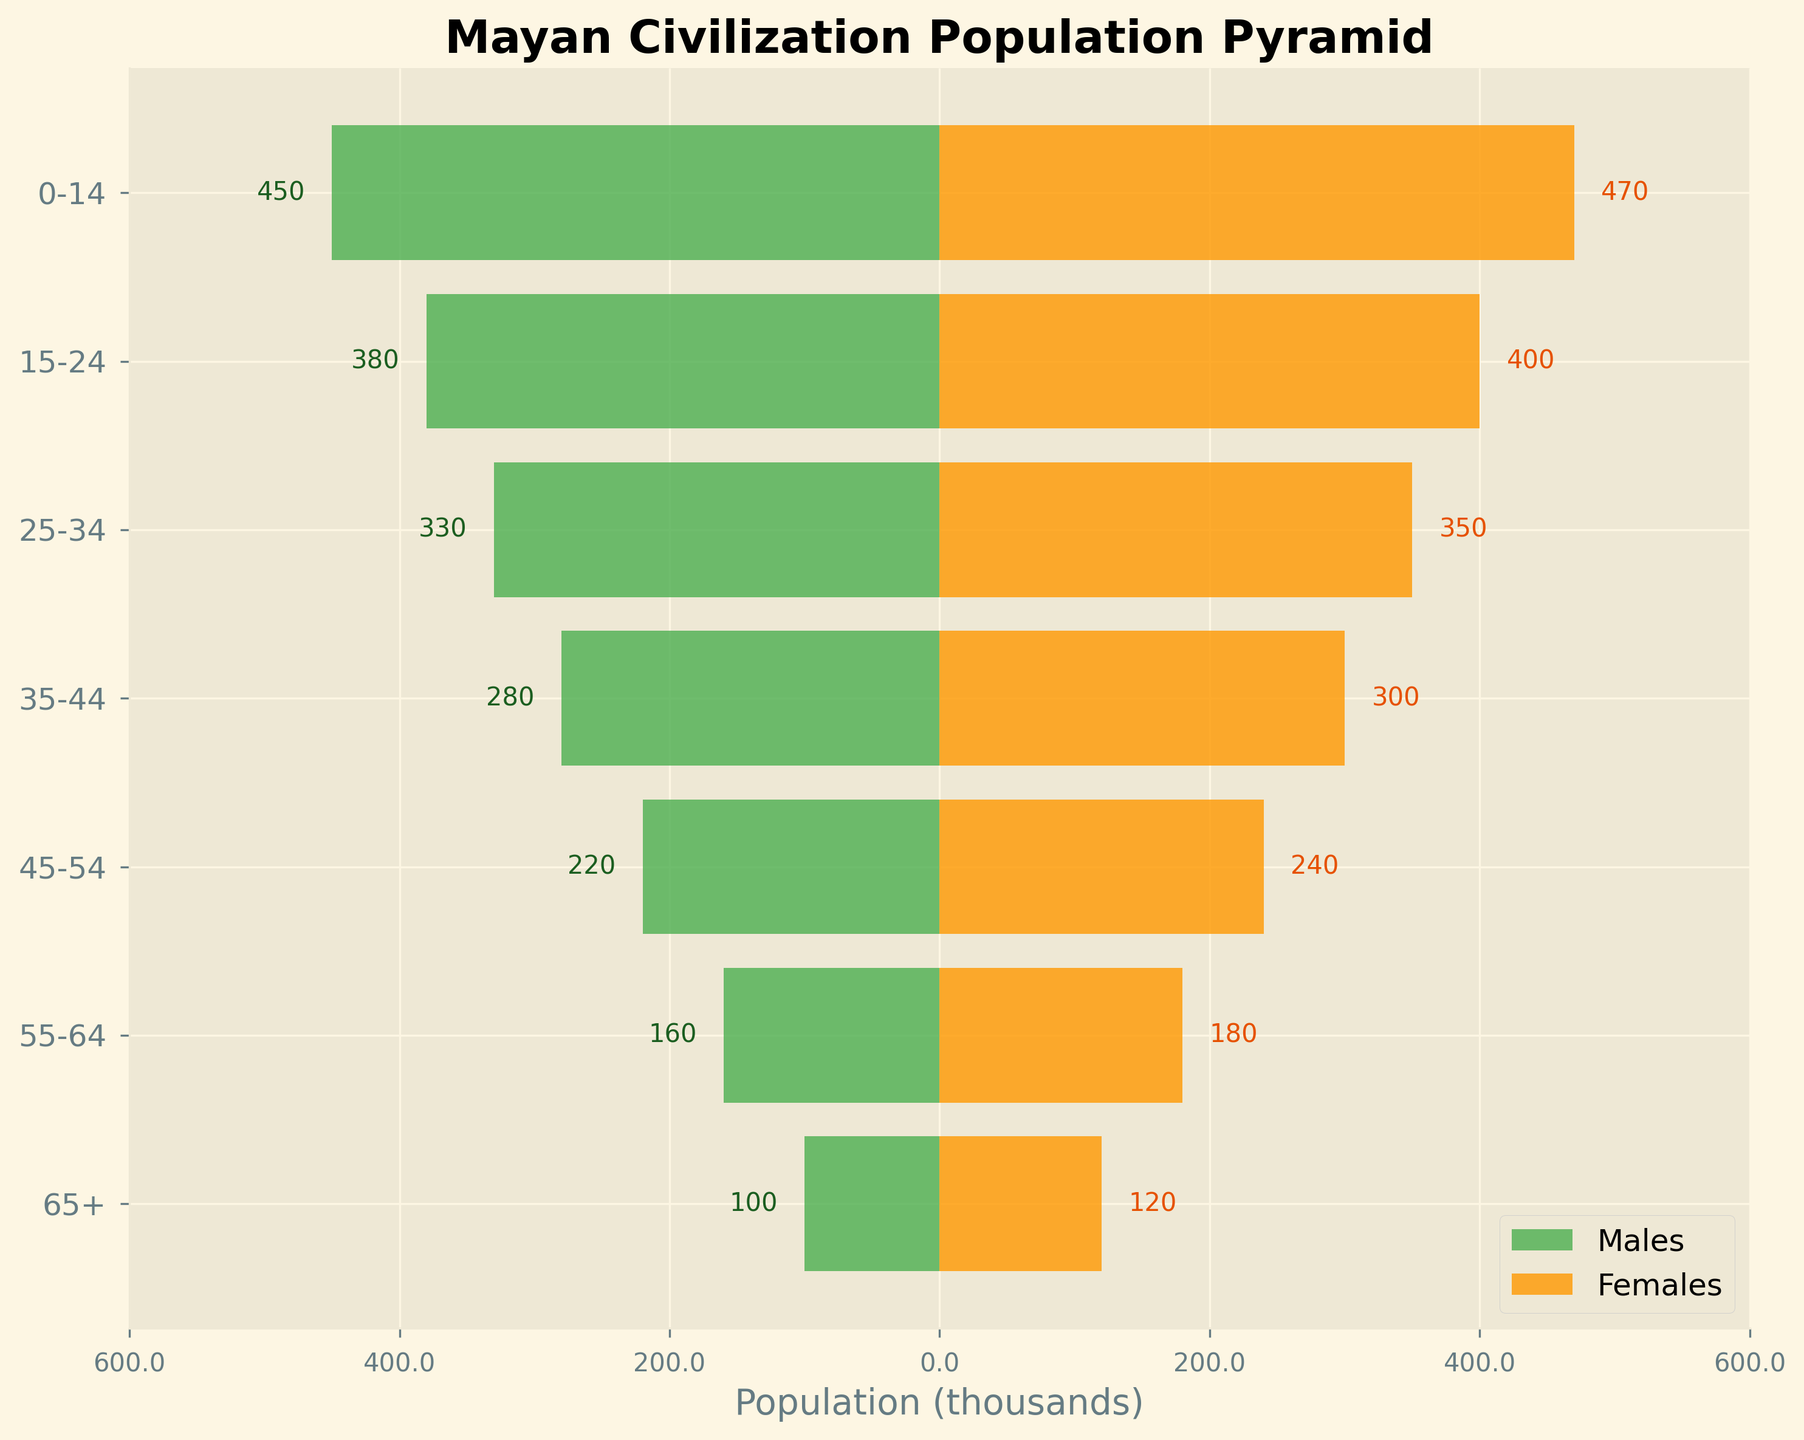What is the title of the figure? The title is written at the top of the figure, summarizing what the data represents.
Answer: Mayan Civilization Population Pyramid Which gender has a higher population in the 0-14 age group? Compare the bar lengths for Males and Females in the 0-14 age group. The orange bar (Females) is longer than the green bar (Males) in this category.
Answer: Females What is the population (in thousands) of Males in the 15-24 age group? Look at the horizontal length of the green bar representing Males in the 15-24 age group. The number is also displayed near the bar. It reads 380.
Answer: 380 What is the difference in population between Males and Females in the 55-64 age group? Subtract the population of Males from Females in the 55-64 age group. Population of Males is 160,000 and Females is 180,000. The difference is 180,000 - 160,000.
Answer: 20,000 Which age group has the smallest female population? Find the shortest orange bar (Females) among all the age groups. The shortest bar belongs to the 65+ age group.
Answer: 65+ What is the total population (in thousands) of the Mayan civilization based on the given data? Add up the populations for Males and Females across all age groups. Total Males are 450 + 380 + 330 + 280 + 220 + 160 + 100 = 1920. Total Females are 470 + 400 + 350 + 300 + 240 + 180 + 120 = 2060. The sum is 1920 + 2060.
Answer: 3980 Which gender has a higher population in the 25-34 age group, and by how much? Compare the populations of Males and Females in the 25-34 age group. Females have 350,000 and Males have 330,000. Subtract Males from Females to find the difference.
Answer: Females, 20,000 How does the population of Males in the 45-54 age group compare to that in the 35-44 age group? Compare the lengths of the green bars for Males in both age groups. The 35-44 group has 280,000 Males, and the 45-54 group has 220,000 Males. The population decreases.
Answer: Decreases What is the average population of Females in the 25-34 and 35-44 age groups? Add the populations of Females in the 25-34 and 35-44 age groups and divide by 2. (350,000 + 300,000) / 2.
Answer: 325,000 What pattern do you observe in the population as age increases? Examine the lengths of the bars and notice the general trend. Both Males and Females show longer bars in younger age groups and shorter bars in older age groups, indicating a decline in population as age increases.
Answer: Declining 